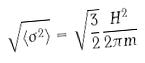<formula> <loc_0><loc_0><loc_500><loc_500>\sqrt { \langle \sigma ^ { 2 } \rangle } = \sqrt { \frac { 3 } { 2 } } { \frac { H ^ { 2 } } { 2 \pi m } }</formula> 